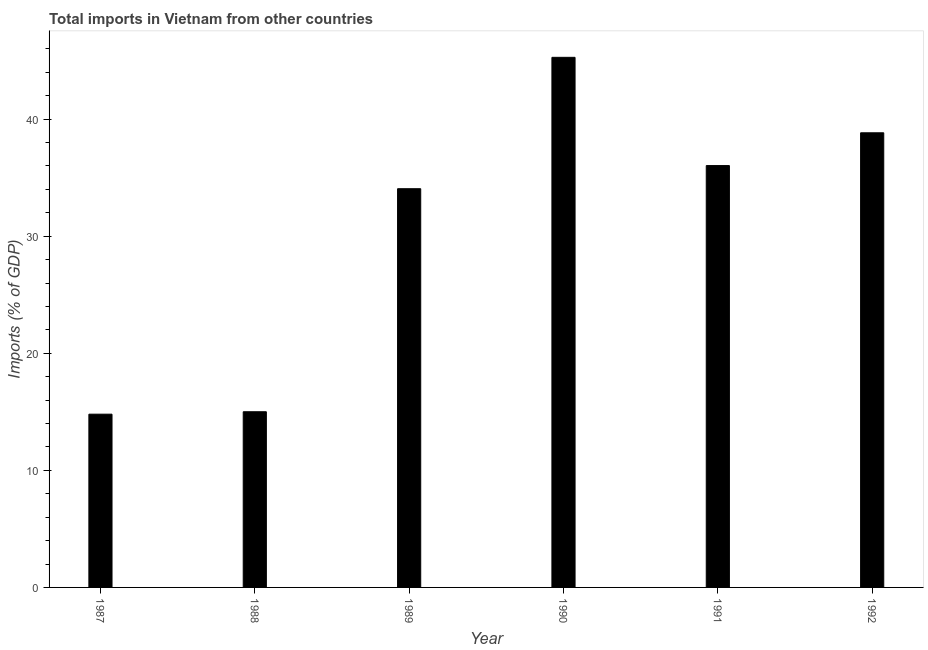What is the title of the graph?
Offer a very short reply. Total imports in Vietnam from other countries. What is the label or title of the Y-axis?
Keep it short and to the point. Imports (% of GDP). What is the total imports in 1988?
Provide a succinct answer. 15.01. Across all years, what is the maximum total imports?
Give a very brief answer. 45.28. Across all years, what is the minimum total imports?
Make the answer very short. 14.8. What is the sum of the total imports?
Make the answer very short. 184. What is the difference between the total imports in 1989 and 1991?
Ensure brevity in your answer.  -1.98. What is the average total imports per year?
Your answer should be compact. 30.67. What is the median total imports?
Keep it short and to the point. 35.04. What is the ratio of the total imports in 1988 to that in 1989?
Ensure brevity in your answer.  0.44. What is the difference between the highest and the second highest total imports?
Your response must be concise. 6.45. What is the difference between the highest and the lowest total imports?
Ensure brevity in your answer.  30.48. In how many years, is the total imports greater than the average total imports taken over all years?
Give a very brief answer. 4. How many bars are there?
Make the answer very short. 6. Are the values on the major ticks of Y-axis written in scientific E-notation?
Your answer should be compact. No. What is the Imports (% of GDP) in 1987?
Your answer should be compact. 14.8. What is the Imports (% of GDP) in 1988?
Your answer should be very brief. 15.01. What is the Imports (% of GDP) in 1989?
Provide a short and direct response. 34.06. What is the Imports (% of GDP) in 1990?
Your response must be concise. 45.28. What is the Imports (% of GDP) in 1991?
Ensure brevity in your answer.  36.03. What is the Imports (% of GDP) in 1992?
Provide a succinct answer. 38.83. What is the difference between the Imports (% of GDP) in 1987 and 1988?
Ensure brevity in your answer.  -0.21. What is the difference between the Imports (% of GDP) in 1987 and 1989?
Your response must be concise. -19.26. What is the difference between the Imports (% of GDP) in 1987 and 1990?
Keep it short and to the point. -30.48. What is the difference between the Imports (% of GDP) in 1987 and 1991?
Provide a succinct answer. -21.23. What is the difference between the Imports (% of GDP) in 1987 and 1992?
Keep it short and to the point. -24.03. What is the difference between the Imports (% of GDP) in 1988 and 1989?
Ensure brevity in your answer.  -19.05. What is the difference between the Imports (% of GDP) in 1988 and 1990?
Your answer should be very brief. -30.27. What is the difference between the Imports (% of GDP) in 1988 and 1991?
Offer a very short reply. -21.03. What is the difference between the Imports (% of GDP) in 1988 and 1992?
Your response must be concise. -23.83. What is the difference between the Imports (% of GDP) in 1989 and 1990?
Keep it short and to the point. -11.22. What is the difference between the Imports (% of GDP) in 1989 and 1991?
Your answer should be compact. -1.98. What is the difference between the Imports (% of GDP) in 1989 and 1992?
Give a very brief answer. -4.78. What is the difference between the Imports (% of GDP) in 1990 and 1991?
Give a very brief answer. 9.25. What is the difference between the Imports (% of GDP) in 1990 and 1992?
Keep it short and to the point. 6.45. What is the difference between the Imports (% of GDP) in 1991 and 1992?
Your answer should be very brief. -2.8. What is the ratio of the Imports (% of GDP) in 1987 to that in 1989?
Provide a short and direct response. 0.43. What is the ratio of the Imports (% of GDP) in 1987 to that in 1990?
Keep it short and to the point. 0.33. What is the ratio of the Imports (% of GDP) in 1987 to that in 1991?
Offer a very short reply. 0.41. What is the ratio of the Imports (% of GDP) in 1987 to that in 1992?
Your answer should be very brief. 0.38. What is the ratio of the Imports (% of GDP) in 1988 to that in 1989?
Offer a terse response. 0.44. What is the ratio of the Imports (% of GDP) in 1988 to that in 1990?
Your answer should be very brief. 0.33. What is the ratio of the Imports (% of GDP) in 1988 to that in 1991?
Ensure brevity in your answer.  0.42. What is the ratio of the Imports (% of GDP) in 1988 to that in 1992?
Keep it short and to the point. 0.39. What is the ratio of the Imports (% of GDP) in 1989 to that in 1990?
Offer a very short reply. 0.75. What is the ratio of the Imports (% of GDP) in 1989 to that in 1991?
Make the answer very short. 0.94. What is the ratio of the Imports (% of GDP) in 1989 to that in 1992?
Offer a terse response. 0.88. What is the ratio of the Imports (% of GDP) in 1990 to that in 1991?
Keep it short and to the point. 1.26. What is the ratio of the Imports (% of GDP) in 1990 to that in 1992?
Provide a succinct answer. 1.17. What is the ratio of the Imports (% of GDP) in 1991 to that in 1992?
Offer a very short reply. 0.93. 